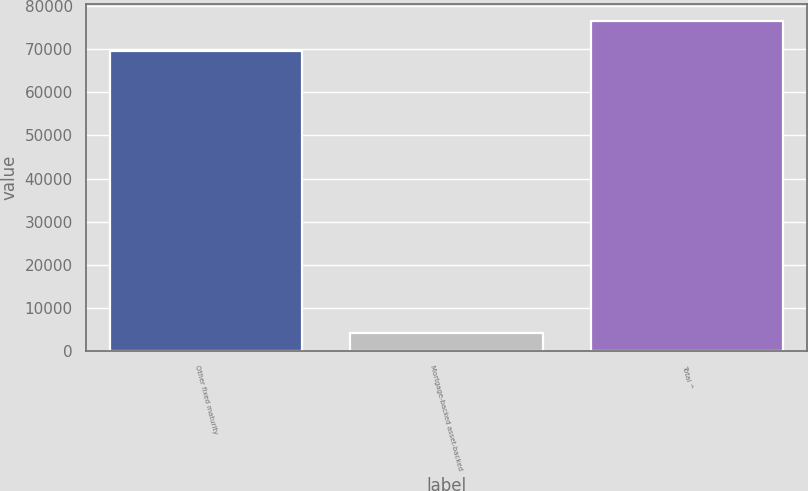Convert chart. <chart><loc_0><loc_0><loc_500><loc_500><bar_chart><fcel>Other fixed maturity<fcel>Mortgage-backed asset-backed<fcel>Total ^<nl><fcel>69609<fcel>4210<fcel>76569.9<nl></chart> 